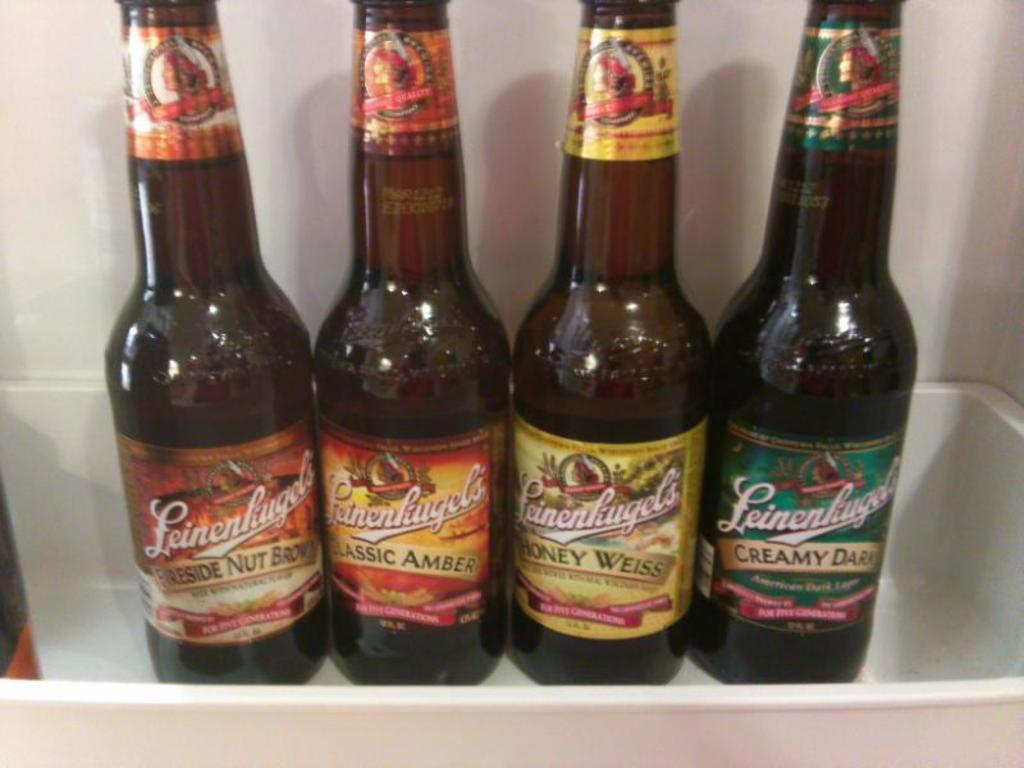What flavor of beer is the third bottle from the left?
Your answer should be compact. Honey weiss. 